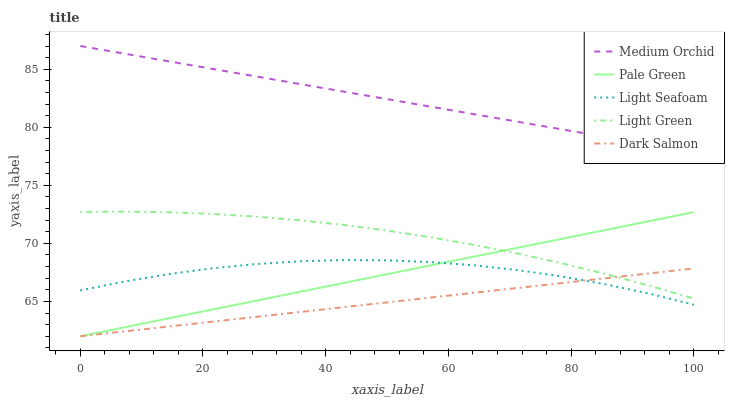Does Dark Salmon have the minimum area under the curve?
Answer yes or no. Yes. Does Medium Orchid have the maximum area under the curve?
Answer yes or no. Yes. Does Light Green have the minimum area under the curve?
Answer yes or no. No. Does Light Green have the maximum area under the curve?
Answer yes or no. No. Is Dark Salmon the smoothest?
Answer yes or no. Yes. Is Light Seafoam the roughest?
Answer yes or no. Yes. Is Medium Orchid the smoothest?
Answer yes or no. No. Is Medium Orchid the roughest?
Answer yes or no. No. Does Pale Green have the lowest value?
Answer yes or no. Yes. Does Light Green have the lowest value?
Answer yes or no. No. Does Medium Orchid have the highest value?
Answer yes or no. Yes. Does Light Green have the highest value?
Answer yes or no. No. Is Light Green less than Medium Orchid?
Answer yes or no. Yes. Is Medium Orchid greater than Light Seafoam?
Answer yes or no. Yes. Does Pale Green intersect Light Seafoam?
Answer yes or no. Yes. Is Pale Green less than Light Seafoam?
Answer yes or no. No. Is Pale Green greater than Light Seafoam?
Answer yes or no. No. Does Light Green intersect Medium Orchid?
Answer yes or no. No. 